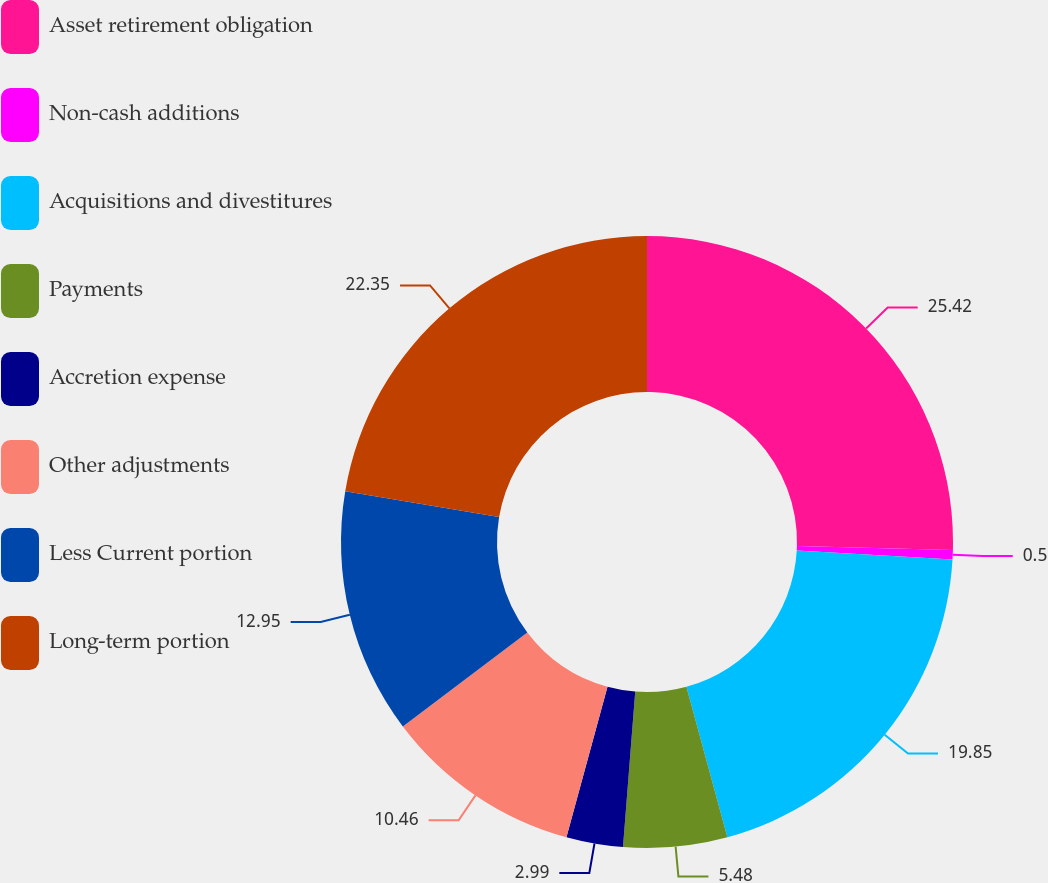Convert chart. <chart><loc_0><loc_0><loc_500><loc_500><pie_chart><fcel>Asset retirement obligation<fcel>Non-cash additions<fcel>Acquisitions and divestitures<fcel>Payments<fcel>Accretion expense<fcel>Other adjustments<fcel>Less Current portion<fcel>Long-term portion<nl><fcel>25.41%<fcel>0.5%<fcel>19.85%<fcel>5.48%<fcel>2.99%<fcel>10.46%<fcel>12.95%<fcel>22.34%<nl></chart> 